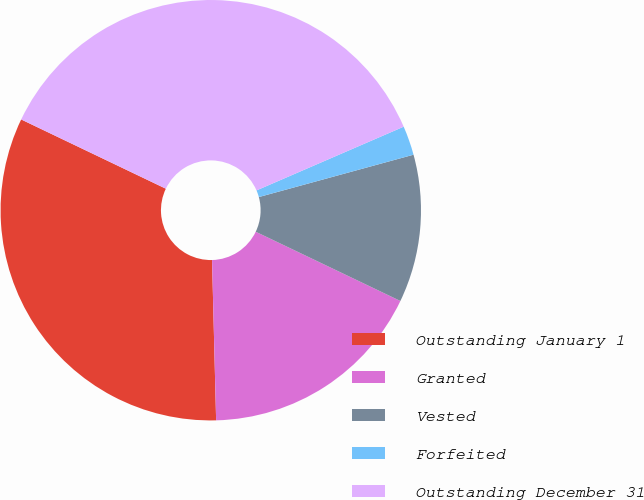<chart> <loc_0><loc_0><loc_500><loc_500><pie_chart><fcel>Outstanding January 1<fcel>Granted<fcel>Vested<fcel>Forfeited<fcel>Outstanding December 31<nl><fcel>32.51%<fcel>17.49%<fcel>11.36%<fcel>2.25%<fcel>36.39%<nl></chart> 